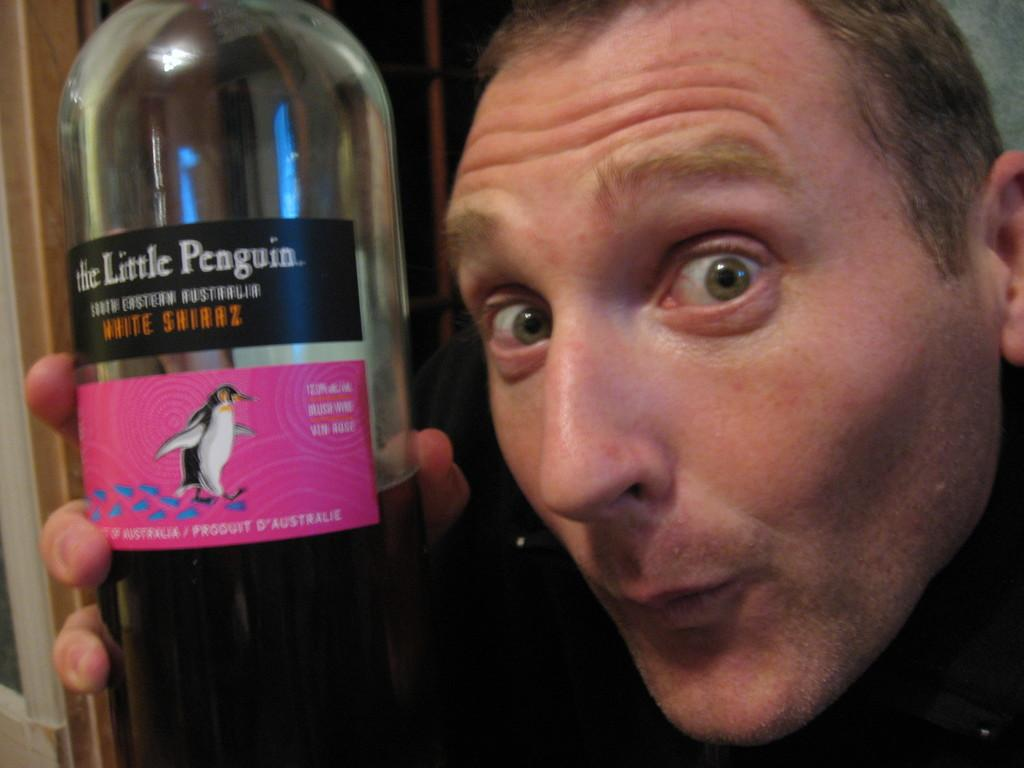What is the main subject of the image? There is a person in the image. What is the person holding in the image? The person is holding a wine bottle. What is the name of the wine bottle? The wine bottle is named "Little penguin." What type of flower can be seen growing in the square range in the image? There is no flower, square, or range present in the image; it features a person holding a wine bottle named "Little penguin." 